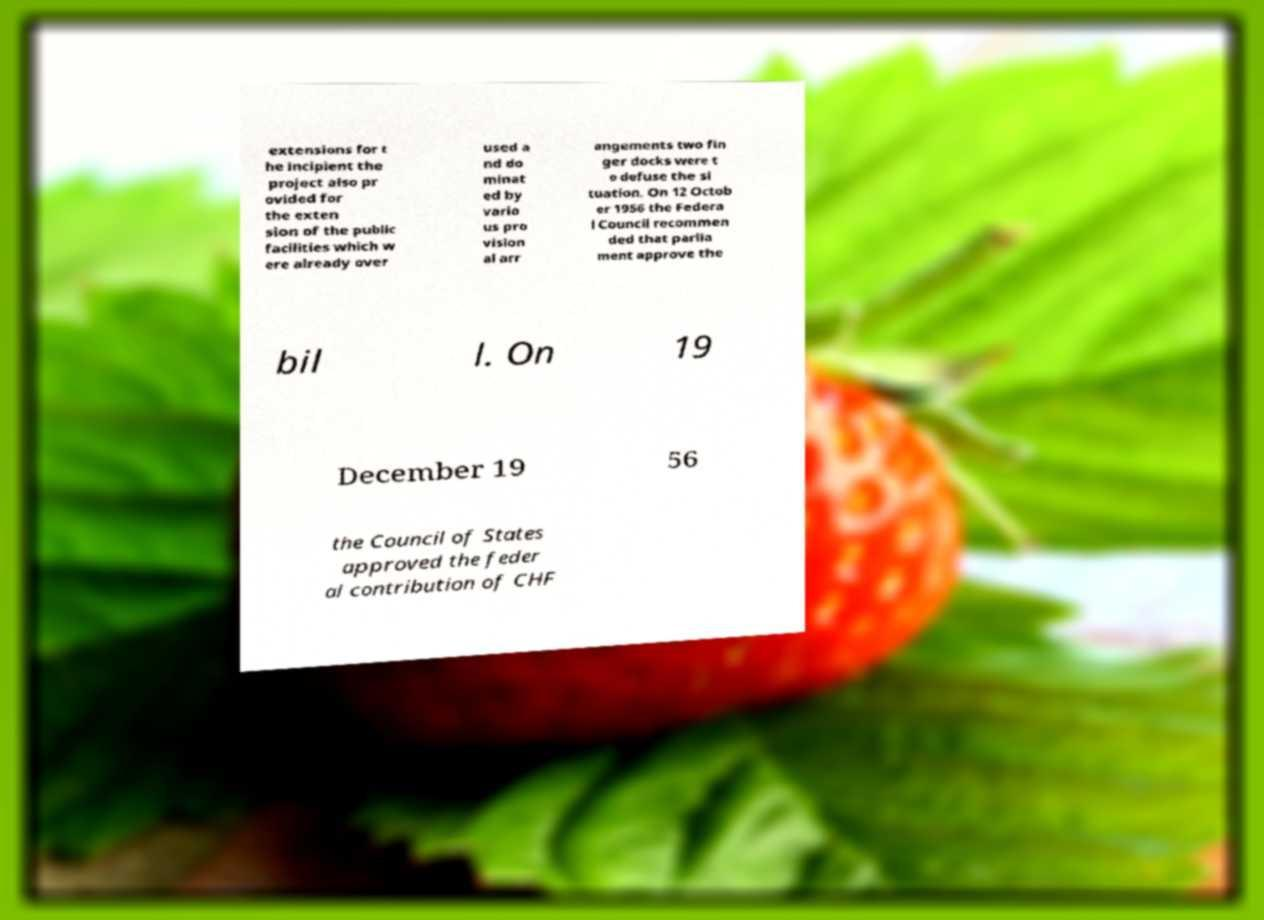Please identify and transcribe the text found in this image. extensions for t he incipient the project also pr ovided for the exten sion of the public facilities which w ere already over used a nd do minat ed by vario us pro vision al arr angements two fin ger docks were t o defuse the si tuation. On 12 Octob er 1956 the Federa l Council recommen ded that parlia ment approve the bil l. On 19 December 19 56 the Council of States approved the feder al contribution of CHF 